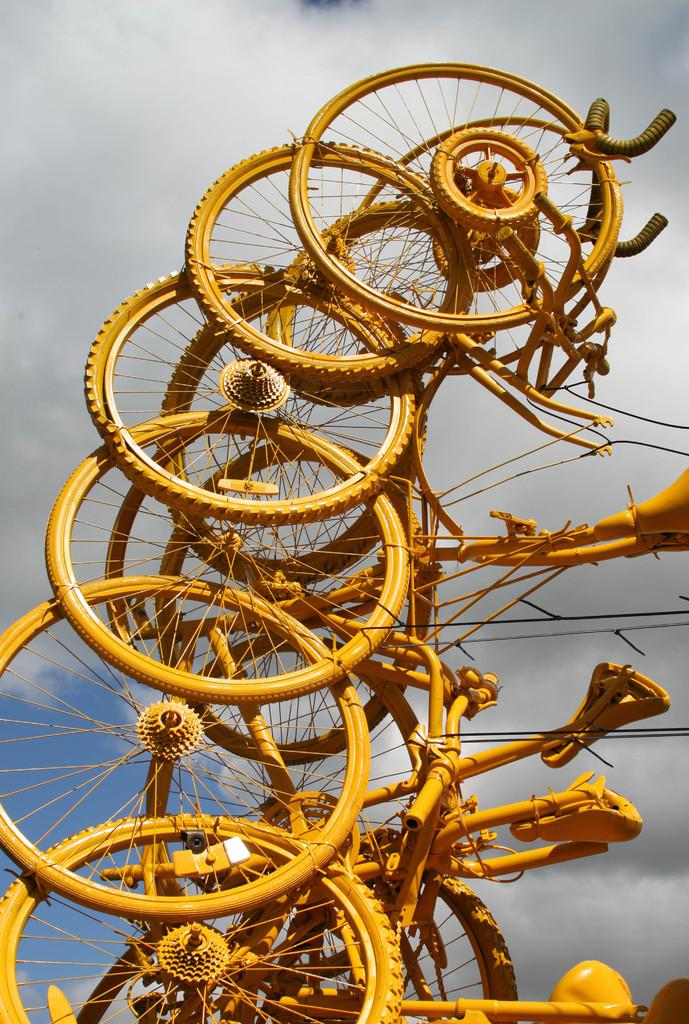What is the main subject of the image? The main subject of the image is many bicycles. What can be seen in the sky in the image? There are clouds visible in the sky in the image. Where is the bomb located in the image? There is no bomb present in the image. What type of furniture is visible in the image? There is no furniture visible in the image. Can you see a cat in the image? There is no cat present in the image. 